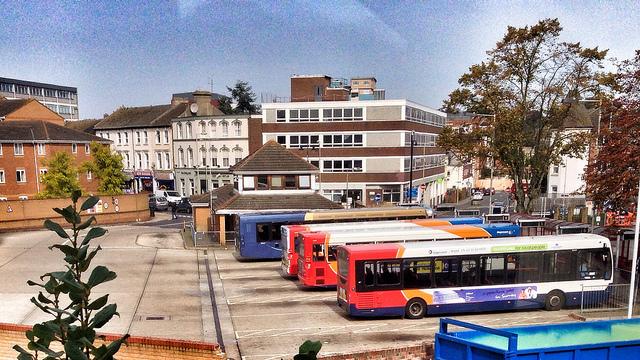How many buses are in the parking lot?
Keep it brief. 4. What form of transportation is there?
Give a very brief answer. Bus. Are the buildings hotels?
Give a very brief answer. Yes. What are the buildings for?
Quick response, please. Business. Is this a poor section of town?
Answer briefly. No. 